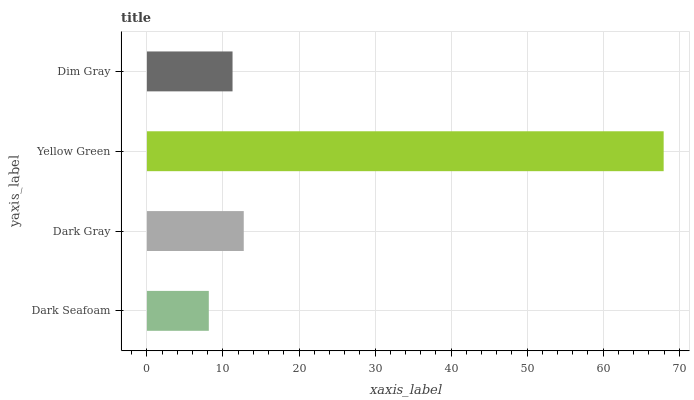Is Dark Seafoam the minimum?
Answer yes or no. Yes. Is Yellow Green the maximum?
Answer yes or no. Yes. Is Dark Gray the minimum?
Answer yes or no. No. Is Dark Gray the maximum?
Answer yes or no. No. Is Dark Gray greater than Dark Seafoam?
Answer yes or no. Yes. Is Dark Seafoam less than Dark Gray?
Answer yes or no. Yes. Is Dark Seafoam greater than Dark Gray?
Answer yes or no. No. Is Dark Gray less than Dark Seafoam?
Answer yes or no. No. Is Dark Gray the high median?
Answer yes or no. Yes. Is Dim Gray the low median?
Answer yes or no. Yes. Is Yellow Green the high median?
Answer yes or no. No. Is Dark Gray the low median?
Answer yes or no. No. 